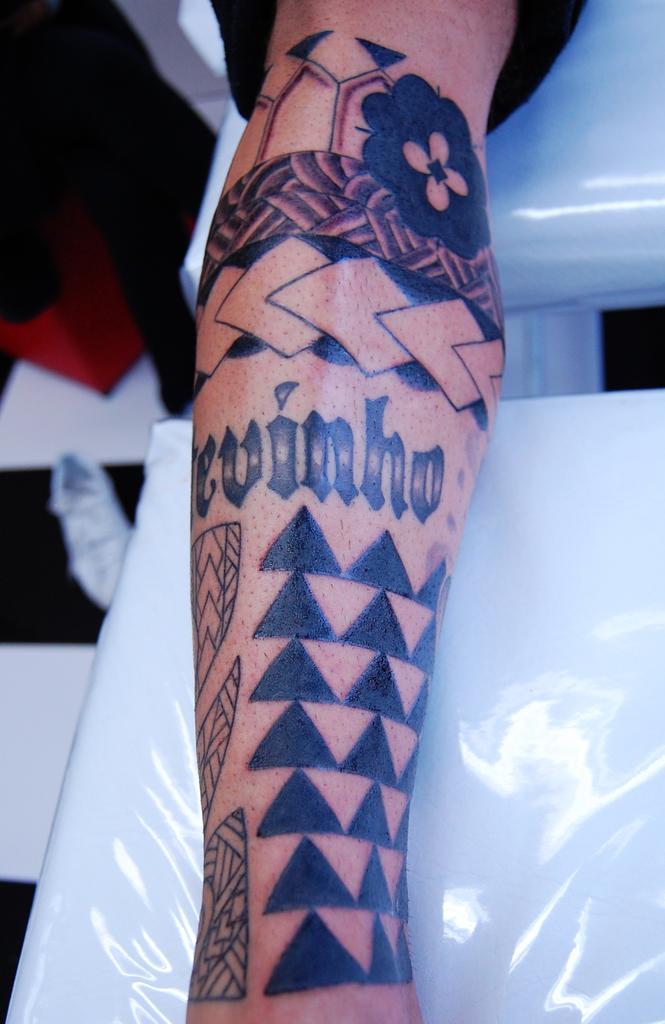What part of the body is visible in the image? There is a person's hand in the image. What distinguishing feature can be seen on the hand? The hand has a tattoo. What is the color of the surface the hand is resting on? The hand is on a white color surface. What time of day is depicted in the image? The image does not depict a specific time of day, as it only shows a person's hand with a tattoo on a white surface. 